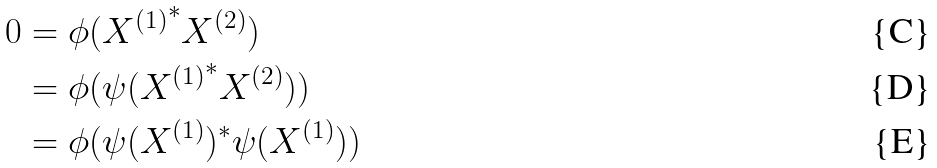Convert formula to latex. <formula><loc_0><loc_0><loc_500><loc_500>0 & = \phi ( { X ^ { ( 1 ) } } ^ { * } X ^ { ( 2 ) } ) \\ & = \phi ( \psi ( { X ^ { ( 1 ) } } ^ { * } X ^ { ( 2 ) } ) ) \\ & = \phi ( \psi ( X ^ { ( 1 ) } ) ^ { * } \psi ( X ^ { ( 1 ) } ) )</formula> 